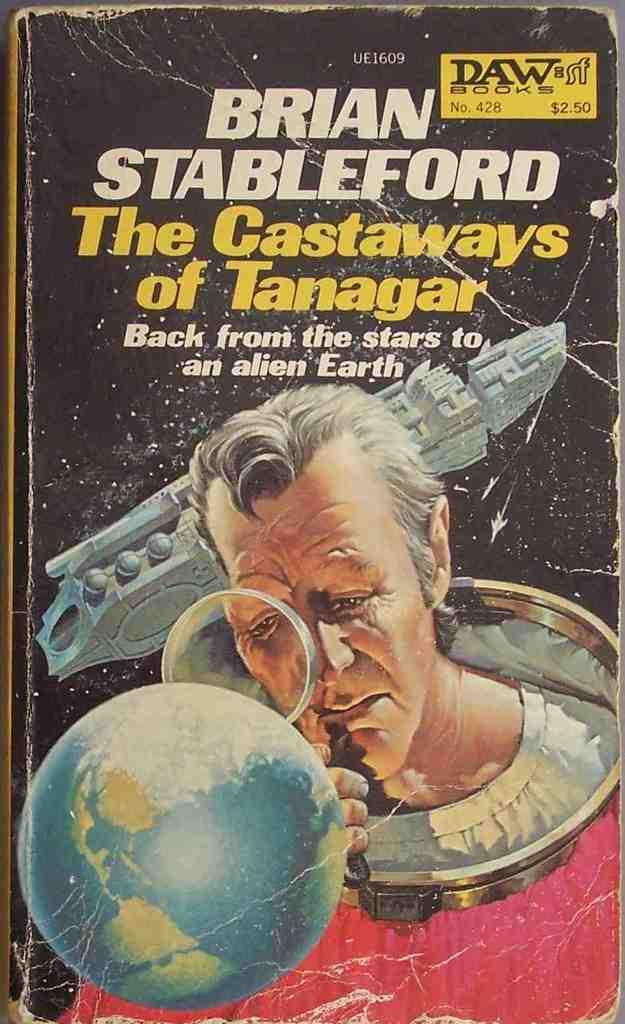<image>
Render a clear and concise summary of the photo. A book cover for The Castaways of Tanagar shows a man looking at a world. 